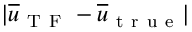Convert formula to latex. <formula><loc_0><loc_0><loc_500><loc_500>| \overline { u } _ { T F } - \overline { u } _ { t r u e } |</formula> 